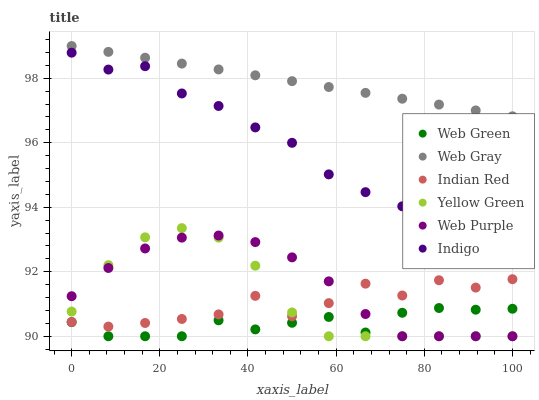Does Web Green have the minimum area under the curve?
Answer yes or no. Yes. Does Web Gray have the maximum area under the curve?
Answer yes or no. Yes. Does Indigo have the minimum area under the curve?
Answer yes or no. No. Does Indigo have the maximum area under the curve?
Answer yes or no. No. Is Web Gray the smoothest?
Answer yes or no. Yes. Is Indian Red the roughest?
Answer yes or no. Yes. Is Indigo the smoothest?
Answer yes or no. No. Is Indigo the roughest?
Answer yes or no. No. Does Yellow Green have the lowest value?
Answer yes or no. Yes. Does Indigo have the lowest value?
Answer yes or no. No. Does Web Gray have the highest value?
Answer yes or no. Yes. Does Indigo have the highest value?
Answer yes or no. No. Is Web Purple less than Indigo?
Answer yes or no. Yes. Is Web Gray greater than Indigo?
Answer yes or no. Yes. Does Indian Red intersect Web Purple?
Answer yes or no. Yes. Is Indian Red less than Web Purple?
Answer yes or no. No. Is Indian Red greater than Web Purple?
Answer yes or no. No. Does Web Purple intersect Indigo?
Answer yes or no. No. 